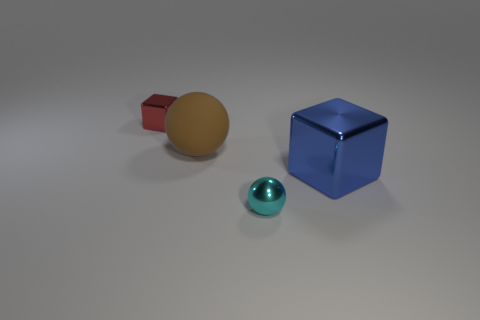Add 3 big blue things. How many objects exist? 7 Subtract all small cyan metal objects. Subtract all blue things. How many objects are left? 2 Add 2 shiny things. How many shiny things are left? 5 Add 4 small rubber cylinders. How many small rubber cylinders exist? 4 Subtract 0 gray spheres. How many objects are left? 4 